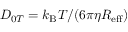Convert formula to latex. <formula><loc_0><loc_0><loc_500><loc_500>D _ { 0 T } = k _ { B } T / ( 6 \pi \eta R _ { e f f } )</formula> 